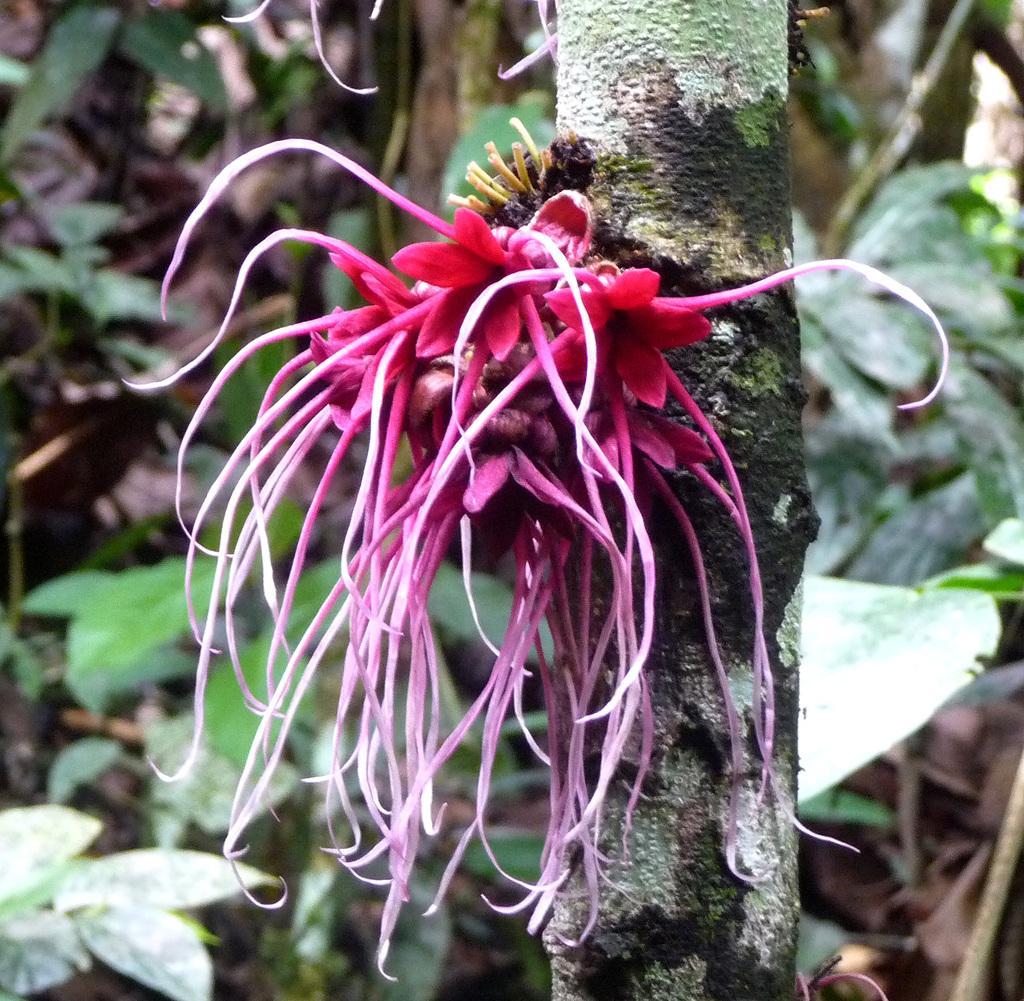Please provide a concise description of this image. In this picture there is a flower plant in the center of the image and there are other plants in the background area of the image. 